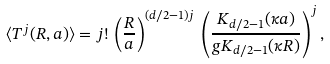<formula> <loc_0><loc_0><loc_500><loc_500>\langle T ^ { j } ( R , a ) \rangle = j ! \, \left ( \frac { R } { a } \right ) ^ { ( d / 2 - 1 ) j } \, \left ( \frac { K _ { d / 2 - 1 } ( \kappa a ) } { g K _ { d / 2 - 1 } ( \kappa R ) } \right ) ^ { j } ,</formula> 